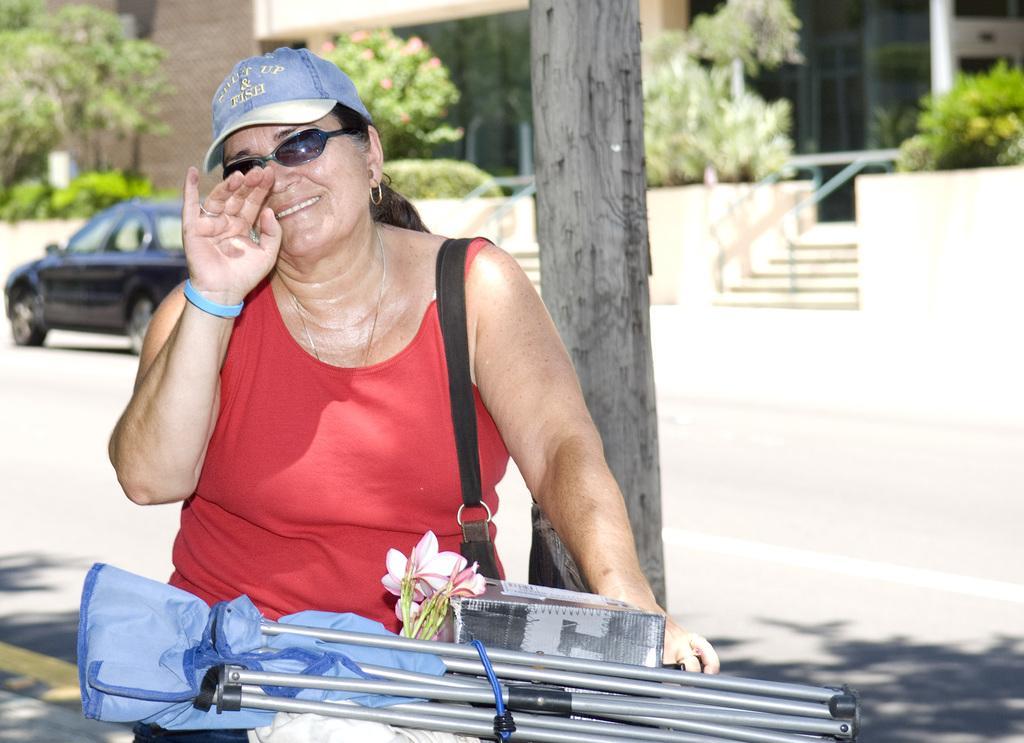How would you summarize this image in a sentence or two? In the foreground of the picture there is a woman and there are flowers, stand and other objects, behind her there is a tree. The background is blurred. In the background there are trees, plants, cars, road, staircase and a building. 